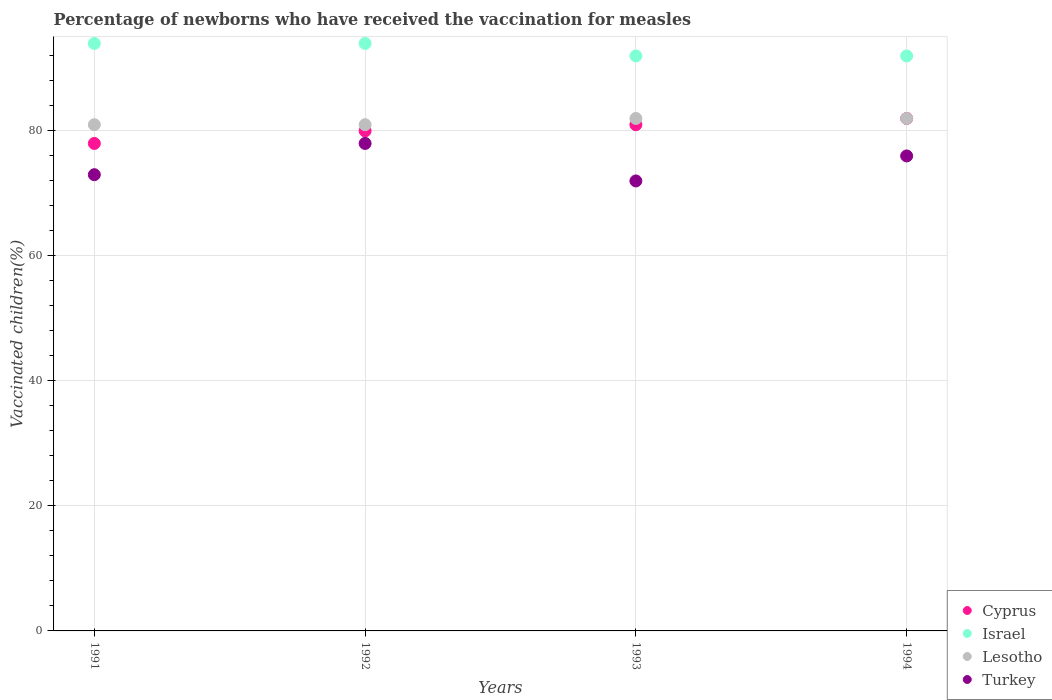How many different coloured dotlines are there?
Keep it short and to the point. 4. Is the number of dotlines equal to the number of legend labels?
Keep it short and to the point. Yes. What is the percentage of vaccinated children in Cyprus in 1992?
Give a very brief answer. 80. Across all years, what is the maximum percentage of vaccinated children in Lesotho?
Give a very brief answer. 82. Across all years, what is the minimum percentage of vaccinated children in Turkey?
Provide a short and direct response. 72. In which year was the percentage of vaccinated children in Israel maximum?
Offer a terse response. 1991. What is the total percentage of vaccinated children in Turkey in the graph?
Your answer should be compact. 299. What is the difference between the percentage of vaccinated children in Israel in 1992 and that in 1994?
Keep it short and to the point. 2. What is the difference between the percentage of vaccinated children in Cyprus in 1993 and the percentage of vaccinated children in Lesotho in 1991?
Ensure brevity in your answer.  0. What is the average percentage of vaccinated children in Turkey per year?
Your answer should be very brief. 74.75. In the year 1992, what is the difference between the percentage of vaccinated children in Israel and percentage of vaccinated children in Turkey?
Give a very brief answer. 16. In how many years, is the percentage of vaccinated children in Turkey greater than 36 %?
Offer a very short reply. 4. What is the ratio of the percentage of vaccinated children in Israel in 1992 to that in 1994?
Your answer should be very brief. 1.02. Is the percentage of vaccinated children in Cyprus in 1992 less than that in 1994?
Keep it short and to the point. Yes. What is the difference between the highest and the second highest percentage of vaccinated children in Lesotho?
Provide a succinct answer. 0. What is the difference between the highest and the lowest percentage of vaccinated children in Lesotho?
Your answer should be compact. 1. In how many years, is the percentage of vaccinated children in Turkey greater than the average percentage of vaccinated children in Turkey taken over all years?
Offer a terse response. 2. Is it the case that in every year, the sum of the percentage of vaccinated children in Israel and percentage of vaccinated children in Lesotho  is greater than the sum of percentage of vaccinated children in Cyprus and percentage of vaccinated children in Turkey?
Your answer should be compact. Yes. Does the percentage of vaccinated children in Lesotho monotonically increase over the years?
Make the answer very short. No. Is the percentage of vaccinated children in Israel strictly greater than the percentage of vaccinated children in Cyprus over the years?
Offer a very short reply. Yes. Is the percentage of vaccinated children in Turkey strictly less than the percentage of vaccinated children in Cyprus over the years?
Your response must be concise. Yes. How many dotlines are there?
Ensure brevity in your answer.  4. Are the values on the major ticks of Y-axis written in scientific E-notation?
Your answer should be very brief. No. Does the graph contain any zero values?
Offer a terse response. No. Does the graph contain grids?
Make the answer very short. Yes. Where does the legend appear in the graph?
Your answer should be compact. Bottom right. What is the title of the graph?
Offer a very short reply. Percentage of newborns who have received the vaccination for measles. Does "Israel" appear as one of the legend labels in the graph?
Your answer should be very brief. Yes. What is the label or title of the Y-axis?
Make the answer very short. Vaccinated children(%). What is the Vaccinated children(%) of Cyprus in 1991?
Your response must be concise. 78. What is the Vaccinated children(%) in Israel in 1991?
Give a very brief answer. 94. What is the Vaccinated children(%) in Turkey in 1991?
Make the answer very short. 73. What is the Vaccinated children(%) of Cyprus in 1992?
Keep it short and to the point. 80. What is the Vaccinated children(%) in Israel in 1992?
Give a very brief answer. 94. What is the Vaccinated children(%) in Turkey in 1992?
Provide a succinct answer. 78. What is the Vaccinated children(%) of Cyprus in 1993?
Offer a very short reply. 81. What is the Vaccinated children(%) of Israel in 1993?
Offer a very short reply. 92. What is the Vaccinated children(%) in Lesotho in 1993?
Ensure brevity in your answer.  82. What is the Vaccinated children(%) of Turkey in 1993?
Keep it short and to the point. 72. What is the Vaccinated children(%) in Israel in 1994?
Keep it short and to the point. 92. What is the Vaccinated children(%) of Lesotho in 1994?
Offer a terse response. 82. Across all years, what is the maximum Vaccinated children(%) in Israel?
Make the answer very short. 94. Across all years, what is the maximum Vaccinated children(%) in Lesotho?
Keep it short and to the point. 82. Across all years, what is the maximum Vaccinated children(%) in Turkey?
Provide a short and direct response. 78. Across all years, what is the minimum Vaccinated children(%) in Cyprus?
Provide a succinct answer. 78. Across all years, what is the minimum Vaccinated children(%) in Israel?
Offer a terse response. 92. Across all years, what is the minimum Vaccinated children(%) in Lesotho?
Offer a terse response. 81. Across all years, what is the minimum Vaccinated children(%) of Turkey?
Offer a terse response. 72. What is the total Vaccinated children(%) of Cyprus in the graph?
Offer a terse response. 321. What is the total Vaccinated children(%) in Israel in the graph?
Your answer should be compact. 372. What is the total Vaccinated children(%) in Lesotho in the graph?
Offer a terse response. 326. What is the total Vaccinated children(%) of Turkey in the graph?
Your response must be concise. 299. What is the difference between the Vaccinated children(%) of Cyprus in 1991 and that in 1992?
Keep it short and to the point. -2. What is the difference between the Vaccinated children(%) in Lesotho in 1991 and that in 1992?
Make the answer very short. 0. What is the difference between the Vaccinated children(%) in Israel in 1991 and that in 1993?
Your answer should be compact. 2. What is the difference between the Vaccinated children(%) of Lesotho in 1991 and that in 1993?
Provide a succinct answer. -1. What is the difference between the Vaccinated children(%) of Cyprus in 1991 and that in 1994?
Your response must be concise. -4. What is the difference between the Vaccinated children(%) of Lesotho in 1992 and that in 1993?
Ensure brevity in your answer.  -1. What is the difference between the Vaccinated children(%) in Lesotho in 1992 and that in 1994?
Give a very brief answer. -1. What is the difference between the Vaccinated children(%) in Israel in 1993 and that in 1994?
Provide a short and direct response. 0. What is the difference between the Vaccinated children(%) in Lesotho in 1993 and that in 1994?
Offer a very short reply. 0. What is the difference between the Vaccinated children(%) of Turkey in 1993 and that in 1994?
Make the answer very short. -4. What is the difference between the Vaccinated children(%) in Cyprus in 1991 and the Vaccinated children(%) in Turkey in 1992?
Provide a short and direct response. 0. What is the difference between the Vaccinated children(%) in Israel in 1991 and the Vaccinated children(%) in Lesotho in 1992?
Ensure brevity in your answer.  13. What is the difference between the Vaccinated children(%) in Israel in 1991 and the Vaccinated children(%) in Turkey in 1992?
Your response must be concise. 16. What is the difference between the Vaccinated children(%) of Lesotho in 1991 and the Vaccinated children(%) of Turkey in 1992?
Keep it short and to the point. 3. What is the difference between the Vaccinated children(%) of Cyprus in 1991 and the Vaccinated children(%) of Israel in 1993?
Your response must be concise. -14. What is the difference between the Vaccinated children(%) of Cyprus in 1991 and the Vaccinated children(%) of Lesotho in 1993?
Your answer should be compact. -4. What is the difference between the Vaccinated children(%) in Cyprus in 1991 and the Vaccinated children(%) in Turkey in 1993?
Provide a short and direct response. 6. What is the difference between the Vaccinated children(%) in Israel in 1991 and the Vaccinated children(%) in Turkey in 1994?
Keep it short and to the point. 18. What is the difference between the Vaccinated children(%) in Cyprus in 1992 and the Vaccinated children(%) in Israel in 1993?
Give a very brief answer. -12. What is the difference between the Vaccinated children(%) of Cyprus in 1992 and the Vaccinated children(%) of Lesotho in 1993?
Make the answer very short. -2. What is the difference between the Vaccinated children(%) of Israel in 1992 and the Vaccinated children(%) of Lesotho in 1993?
Provide a succinct answer. 12. What is the difference between the Vaccinated children(%) of Lesotho in 1992 and the Vaccinated children(%) of Turkey in 1993?
Your response must be concise. 9. What is the difference between the Vaccinated children(%) in Cyprus in 1992 and the Vaccinated children(%) in Lesotho in 1994?
Provide a short and direct response. -2. What is the difference between the Vaccinated children(%) in Israel in 1992 and the Vaccinated children(%) in Lesotho in 1994?
Offer a very short reply. 12. What is the difference between the Vaccinated children(%) of Cyprus in 1993 and the Vaccinated children(%) of Israel in 1994?
Provide a succinct answer. -11. What is the difference between the Vaccinated children(%) of Israel in 1993 and the Vaccinated children(%) of Lesotho in 1994?
Ensure brevity in your answer.  10. What is the average Vaccinated children(%) of Cyprus per year?
Provide a short and direct response. 80.25. What is the average Vaccinated children(%) in Israel per year?
Keep it short and to the point. 93. What is the average Vaccinated children(%) in Lesotho per year?
Your answer should be very brief. 81.5. What is the average Vaccinated children(%) of Turkey per year?
Offer a terse response. 74.75. In the year 1991, what is the difference between the Vaccinated children(%) of Cyprus and Vaccinated children(%) of Lesotho?
Ensure brevity in your answer.  -3. In the year 1991, what is the difference between the Vaccinated children(%) of Israel and Vaccinated children(%) of Turkey?
Give a very brief answer. 21. In the year 1991, what is the difference between the Vaccinated children(%) of Lesotho and Vaccinated children(%) of Turkey?
Give a very brief answer. 8. In the year 1992, what is the difference between the Vaccinated children(%) of Cyprus and Vaccinated children(%) of Israel?
Your answer should be very brief. -14. In the year 1992, what is the difference between the Vaccinated children(%) of Cyprus and Vaccinated children(%) of Turkey?
Your response must be concise. 2. In the year 1992, what is the difference between the Vaccinated children(%) of Israel and Vaccinated children(%) of Turkey?
Your answer should be compact. 16. In the year 1994, what is the difference between the Vaccinated children(%) in Cyprus and Vaccinated children(%) in Israel?
Make the answer very short. -10. In the year 1994, what is the difference between the Vaccinated children(%) in Cyprus and Vaccinated children(%) in Lesotho?
Your answer should be very brief. 0. In the year 1994, what is the difference between the Vaccinated children(%) in Cyprus and Vaccinated children(%) in Turkey?
Make the answer very short. 6. What is the ratio of the Vaccinated children(%) in Cyprus in 1991 to that in 1992?
Your answer should be very brief. 0.97. What is the ratio of the Vaccinated children(%) in Turkey in 1991 to that in 1992?
Make the answer very short. 0.94. What is the ratio of the Vaccinated children(%) of Israel in 1991 to that in 1993?
Make the answer very short. 1.02. What is the ratio of the Vaccinated children(%) of Turkey in 1991 to that in 1993?
Offer a terse response. 1.01. What is the ratio of the Vaccinated children(%) in Cyprus in 1991 to that in 1994?
Keep it short and to the point. 0.95. What is the ratio of the Vaccinated children(%) of Israel in 1991 to that in 1994?
Keep it short and to the point. 1.02. What is the ratio of the Vaccinated children(%) in Lesotho in 1991 to that in 1994?
Ensure brevity in your answer.  0.99. What is the ratio of the Vaccinated children(%) of Turkey in 1991 to that in 1994?
Ensure brevity in your answer.  0.96. What is the ratio of the Vaccinated children(%) in Cyprus in 1992 to that in 1993?
Your answer should be very brief. 0.99. What is the ratio of the Vaccinated children(%) in Israel in 1992 to that in 1993?
Offer a very short reply. 1.02. What is the ratio of the Vaccinated children(%) of Turkey in 1992 to that in 1993?
Your answer should be compact. 1.08. What is the ratio of the Vaccinated children(%) in Cyprus in 1992 to that in 1994?
Your response must be concise. 0.98. What is the ratio of the Vaccinated children(%) in Israel in 1992 to that in 1994?
Provide a short and direct response. 1.02. What is the ratio of the Vaccinated children(%) in Turkey in 1992 to that in 1994?
Keep it short and to the point. 1.03. What is the difference between the highest and the second highest Vaccinated children(%) in Israel?
Offer a terse response. 0. What is the difference between the highest and the second highest Vaccinated children(%) in Lesotho?
Keep it short and to the point. 0. What is the difference between the highest and the second highest Vaccinated children(%) in Turkey?
Offer a very short reply. 2. What is the difference between the highest and the lowest Vaccinated children(%) in Cyprus?
Provide a succinct answer. 4. 